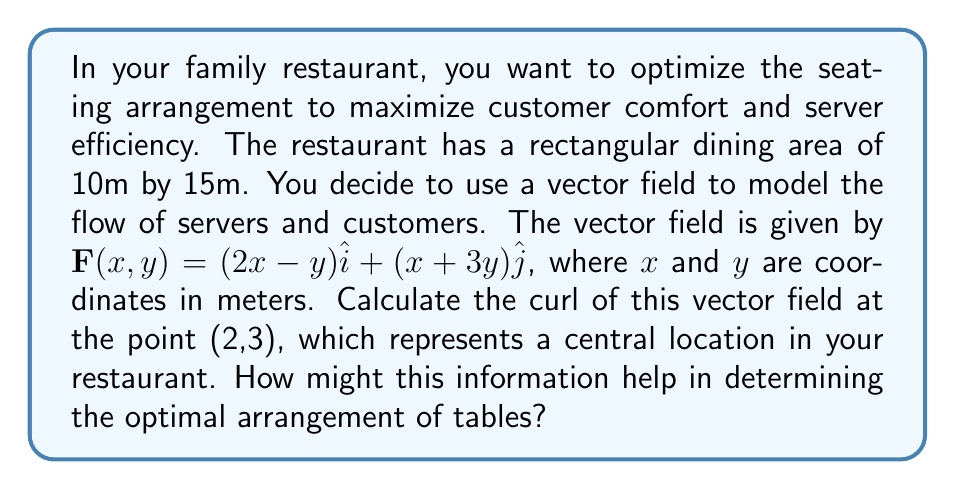Solve this math problem. To solve this problem, we'll follow these steps:

1) The curl of a vector field $\mathbf{F}(x,y) = P(x,y)\hat{i} + Q(x,y)\hat{j}$ in two dimensions is given by:

   $\text{curl } \mathbf{F} = \nabla \times \mathbf{F} = \left(\frac{\partial Q}{\partial x} - \frac{\partial P}{\partial y}\right)\hat{k}$

2) In our case, $P(x,y) = 2x-y$ and $Q(x,y) = x+3y$

3) We need to calculate:
   $\frac{\partial Q}{\partial x} = \frac{\partial}{\partial x}(x+3y) = 1$
   $\frac{\partial P}{\partial y} = \frac{\partial}{\partial y}(2x-y) = -1$

4) Substituting into the curl formula:
   $\text{curl } \mathbf{F} = (1 - (-1))\hat{k} = 2\hat{k}$

5) This result is constant, meaning it's the same at all points, including (2,3).

The curl represents the tendency for rotation in the flow. A positive curl (as we have here) indicates a counterclockwise rotation. In the context of the restaurant, this suggests that there's a natural tendency for movement to circulate counterclockwise.

This information can help in arranging tables by:
- Placing tables to facilitate this natural flow, perhaps in a circular or semicircular arrangement.
- Positioning the entrance and exit to align with this flow.
- Arranging server stations to take advantage of the counterclockwise movement.

By working with, rather than against, this natural flow, you can potentially improve server efficiency and customer comfort.
Answer: $2\hat{k}$ 